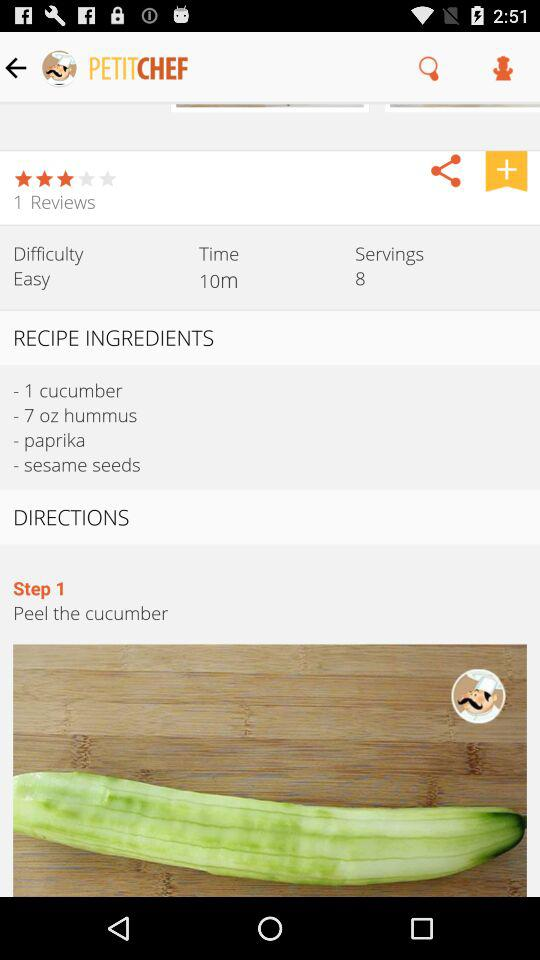How many cucumbers are there? There is 1 cucumber. 